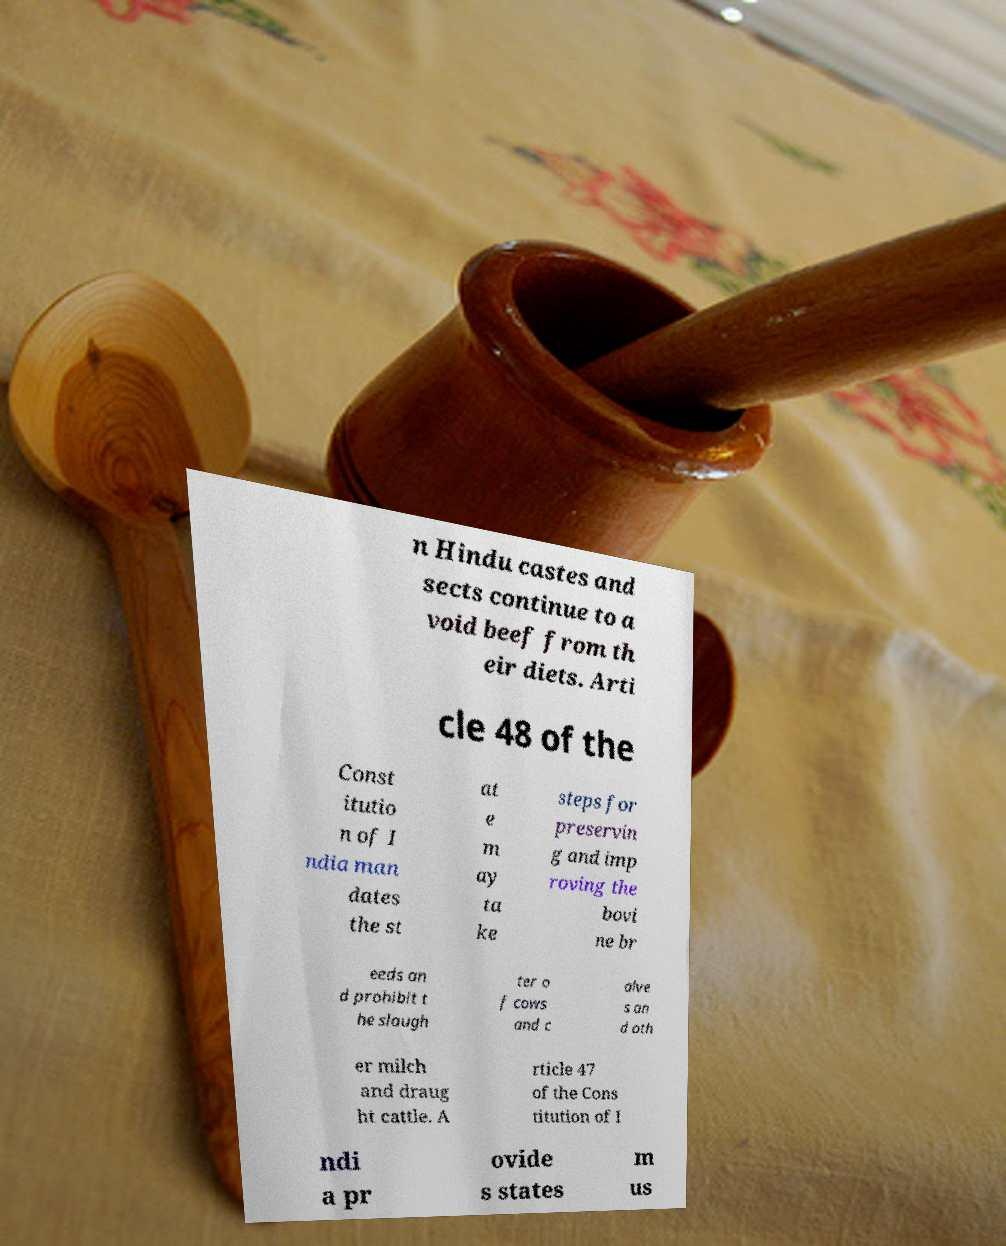What messages or text are displayed in this image? I need them in a readable, typed format. n Hindu castes and sects continue to a void beef from th eir diets. Arti cle 48 of the Const itutio n of I ndia man dates the st at e m ay ta ke steps for preservin g and imp roving the bovi ne br eeds an d prohibit t he slaugh ter o f cows and c alve s an d oth er milch and draug ht cattle. A rticle 47 of the Cons titution of I ndi a pr ovide s states m us 